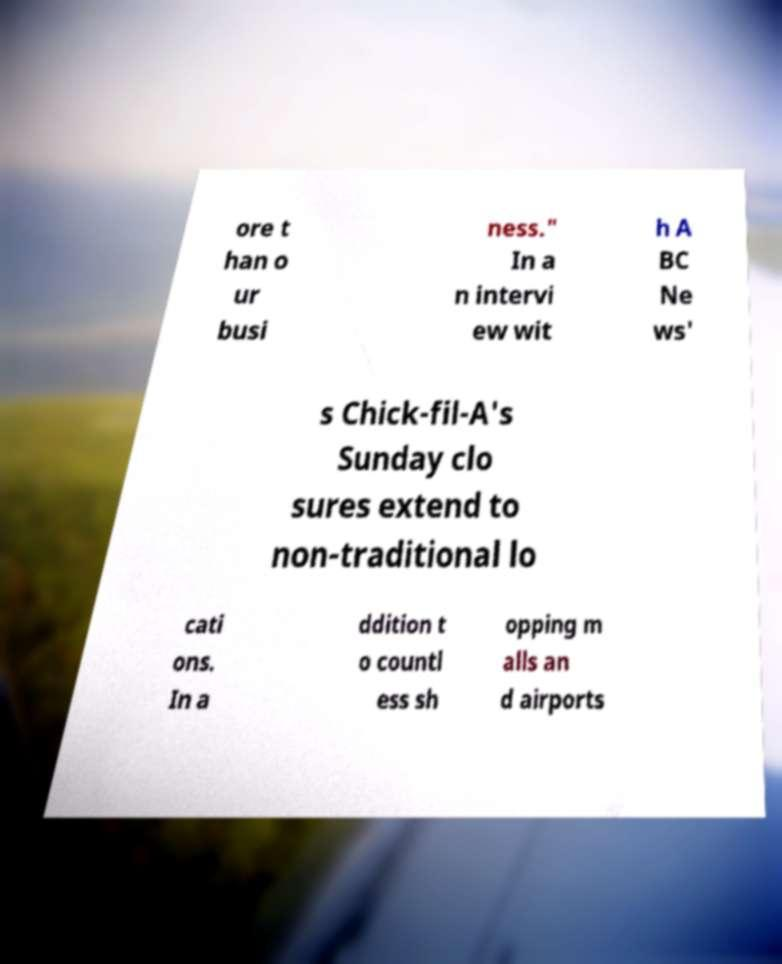Can you read and provide the text displayed in the image?This photo seems to have some interesting text. Can you extract and type it out for me? ore t han o ur busi ness." In a n intervi ew wit h A BC Ne ws' s Chick-fil-A's Sunday clo sures extend to non-traditional lo cati ons. In a ddition t o countl ess sh opping m alls an d airports 